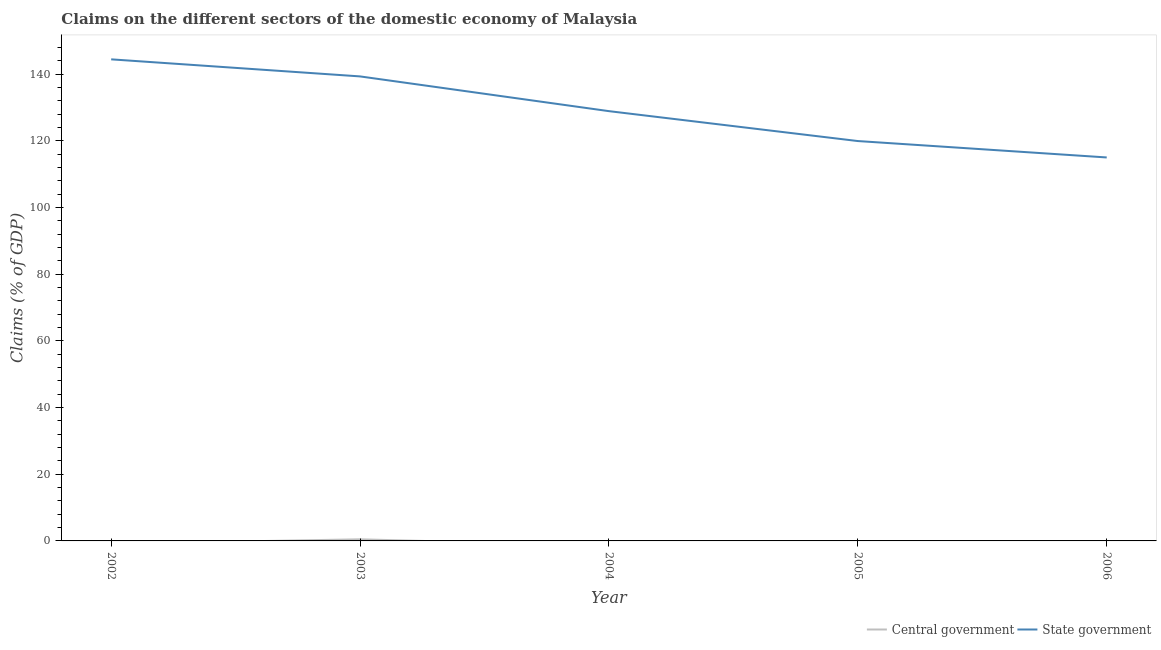Does the line corresponding to claims on central government intersect with the line corresponding to claims on state government?
Your response must be concise. No. What is the claims on state government in 2002?
Make the answer very short. 144.49. Across all years, what is the maximum claims on state government?
Your response must be concise. 144.49. What is the total claims on central government in the graph?
Provide a succinct answer. 0.48. What is the difference between the claims on state government in 2002 and that in 2003?
Your answer should be compact. 5.12. What is the difference between the claims on state government in 2004 and the claims on central government in 2003?
Keep it short and to the point. 128.46. What is the average claims on central government per year?
Offer a terse response. 0.1. In the year 2003, what is the difference between the claims on central government and claims on state government?
Your response must be concise. -138.88. In how many years, is the claims on state government greater than 132 %?
Your answer should be compact. 2. What is the ratio of the claims on state government in 2002 to that in 2005?
Keep it short and to the point. 1.2. What is the difference between the highest and the second highest claims on state government?
Ensure brevity in your answer.  5.12. What is the difference between the highest and the lowest claims on state government?
Provide a succinct answer. 29.44. Is the sum of the claims on state government in 2002 and 2003 greater than the maximum claims on central government across all years?
Ensure brevity in your answer.  Yes. Is the claims on state government strictly greater than the claims on central government over the years?
Your answer should be very brief. Yes. How many years are there in the graph?
Your response must be concise. 5. Are the values on the major ticks of Y-axis written in scientific E-notation?
Ensure brevity in your answer.  No. Does the graph contain grids?
Your response must be concise. No. How many legend labels are there?
Make the answer very short. 2. How are the legend labels stacked?
Offer a very short reply. Horizontal. What is the title of the graph?
Make the answer very short. Claims on the different sectors of the domestic economy of Malaysia. What is the label or title of the Y-axis?
Your response must be concise. Claims (% of GDP). What is the Claims (% of GDP) in State government in 2002?
Provide a succinct answer. 144.49. What is the Claims (% of GDP) in Central government in 2003?
Your answer should be very brief. 0.48. What is the Claims (% of GDP) in State government in 2003?
Make the answer very short. 139.37. What is the Claims (% of GDP) of State government in 2004?
Provide a succinct answer. 128.94. What is the Claims (% of GDP) of Central government in 2005?
Your answer should be compact. 0. What is the Claims (% of GDP) in State government in 2005?
Your answer should be very brief. 119.97. What is the Claims (% of GDP) of State government in 2006?
Offer a terse response. 115.05. Across all years, what is the maximum Claims (% of GDP) in Central government?
Your answer should be very brief. 0.48. Across all years, what is the maximum Claims (% of GDP) of State government?
Your answer should be compact. 144.49. Across all years, what is the minimum Claims (% of GDP) of State government?
Make the answer very short. 115.05. What is the total Claims (% of GDP) in Central government in the graph?
Make the answer very short. 0.48. What is the total Claims (% of GDP) of State government in the graph?
Provide a short and direct response. 647.82. What is the difference between the Claims (% of GDP) of State government in 2002 and that in 2003?
Offer a terse response. 5.12. What is the difference between the Claims (% of GDP) of State government in 2002 and that in 2004?
Provide a succinct answer. 15.54. What is the difference between the Claims (% of GDP) in State government in 2002 and that in 2005?
Your answer should be compact. 24.52. What is the difference between the Claims (% of GDP) in State government in 2002 and that in 2006?
Provide a succinct answer. 29.44. What is the difference between the Claims (% of GDP) of State government in 2003 and that in 2004?
Offer a very short reply. 10.42. What is the difference between the Claims (% of GDP) in State government in 2003 and that in 2005?
Your response must be concise. 19.39. What is the difference between the Claims (% of GDP) in State government in 2003 and that in 2006?
Your answer should be compact. 24.31. What is the difference between the Claims (% of GDP) of State government in 2004 and that in 2005?
Your answer should be compact. 8.97. What is the difference between the Claims (% of GDP) of State government in 2004 and that in 2006?
Your answer should be very brief. 13.89. What is the difference between the Claims (% of GDP) in State government in 2005 and that in 2006?
Keep it short and to the point. 4.92. What is the difference between the Claims (% of GDP) in Central government in 2003 and the Claims (% of GDP) in State government in 2004?
Your response must be concise. -128.46. What is the difference between the Claims (% of GDP) in Central government in 2003 and the Claims (% of GDP) in State government in 2005?
Provide a succinct answer. -119.49. What is the difference between the Claims (% of GDP) of Central government in 2003 and the Claims (% of GDP) of State government in 2006?
Ensure brevity in your answer.  -114.57. What is the average Claims (% of GDP) in Central government per year?
Give a very brief answer. 0.1. What is the average Claims (% of GDP) in State government per year?
Provide a succinct answer. 129.56. In the year 2003, what is the difference between the Claims (% of GDP) of Central government and Claims (% of GDP) of State government?
Ensure brevity in your answer.  -138.88. What is the ratio of the Claims (% of GDP) in State government in 2002 to that in 2003?
Your answer should be compact. 1.04. What is the ratio of the Claims (% of GDP) in State government in 2002 to that in 2004?
Make the answer very short. 1.12. What is the ratio of the Claims (% of GDP) in State government in 2002 to that in 2005?
Keep it short and to the point. 1.2. What is the ratio of the Claims (% of GDP) in State government in 2002 to that in 2006?
Give a very brief answer. 1.26. What is the ratio of the Claims (% of GDP) in State government in 2003 to that in 2004?
Your answer should be compact. 1.08. What is the ratio of the Claims (% of GDP) in State government in 2003 to that in 2005?
Provide a succinct answer. 1.16. What is the ratio of the Claims (% of GDP) in State government in 2003 to that in 2006?
Your answer should be very brief. 1.21. What is the ratio of the Claims (% of GDP) of State government in 2004 to that in 2005?
Provide a succinct answer. 1.07. What is the ratio of the Claims (% of GDP) of State government in 2004 to that in 2006?
Make the answer very short. 1.12. What is the ratio of the Claims (% of GDP) of State government in 2005 to that in 2006?
Keep it short and to the point. 1.04. What is the difference between the highest and the second highest Claims (% of GDP) in State government?
Ensure brevity in your answer.  5.12. What is the difference between the highest and the lowest Claims (% of GDP) of Central government?
Offer a very short reply. 0.48. What is the difference between the highest and the lowest Claims (% of GDP) in State government?
Your response must be concise. 29.44. 